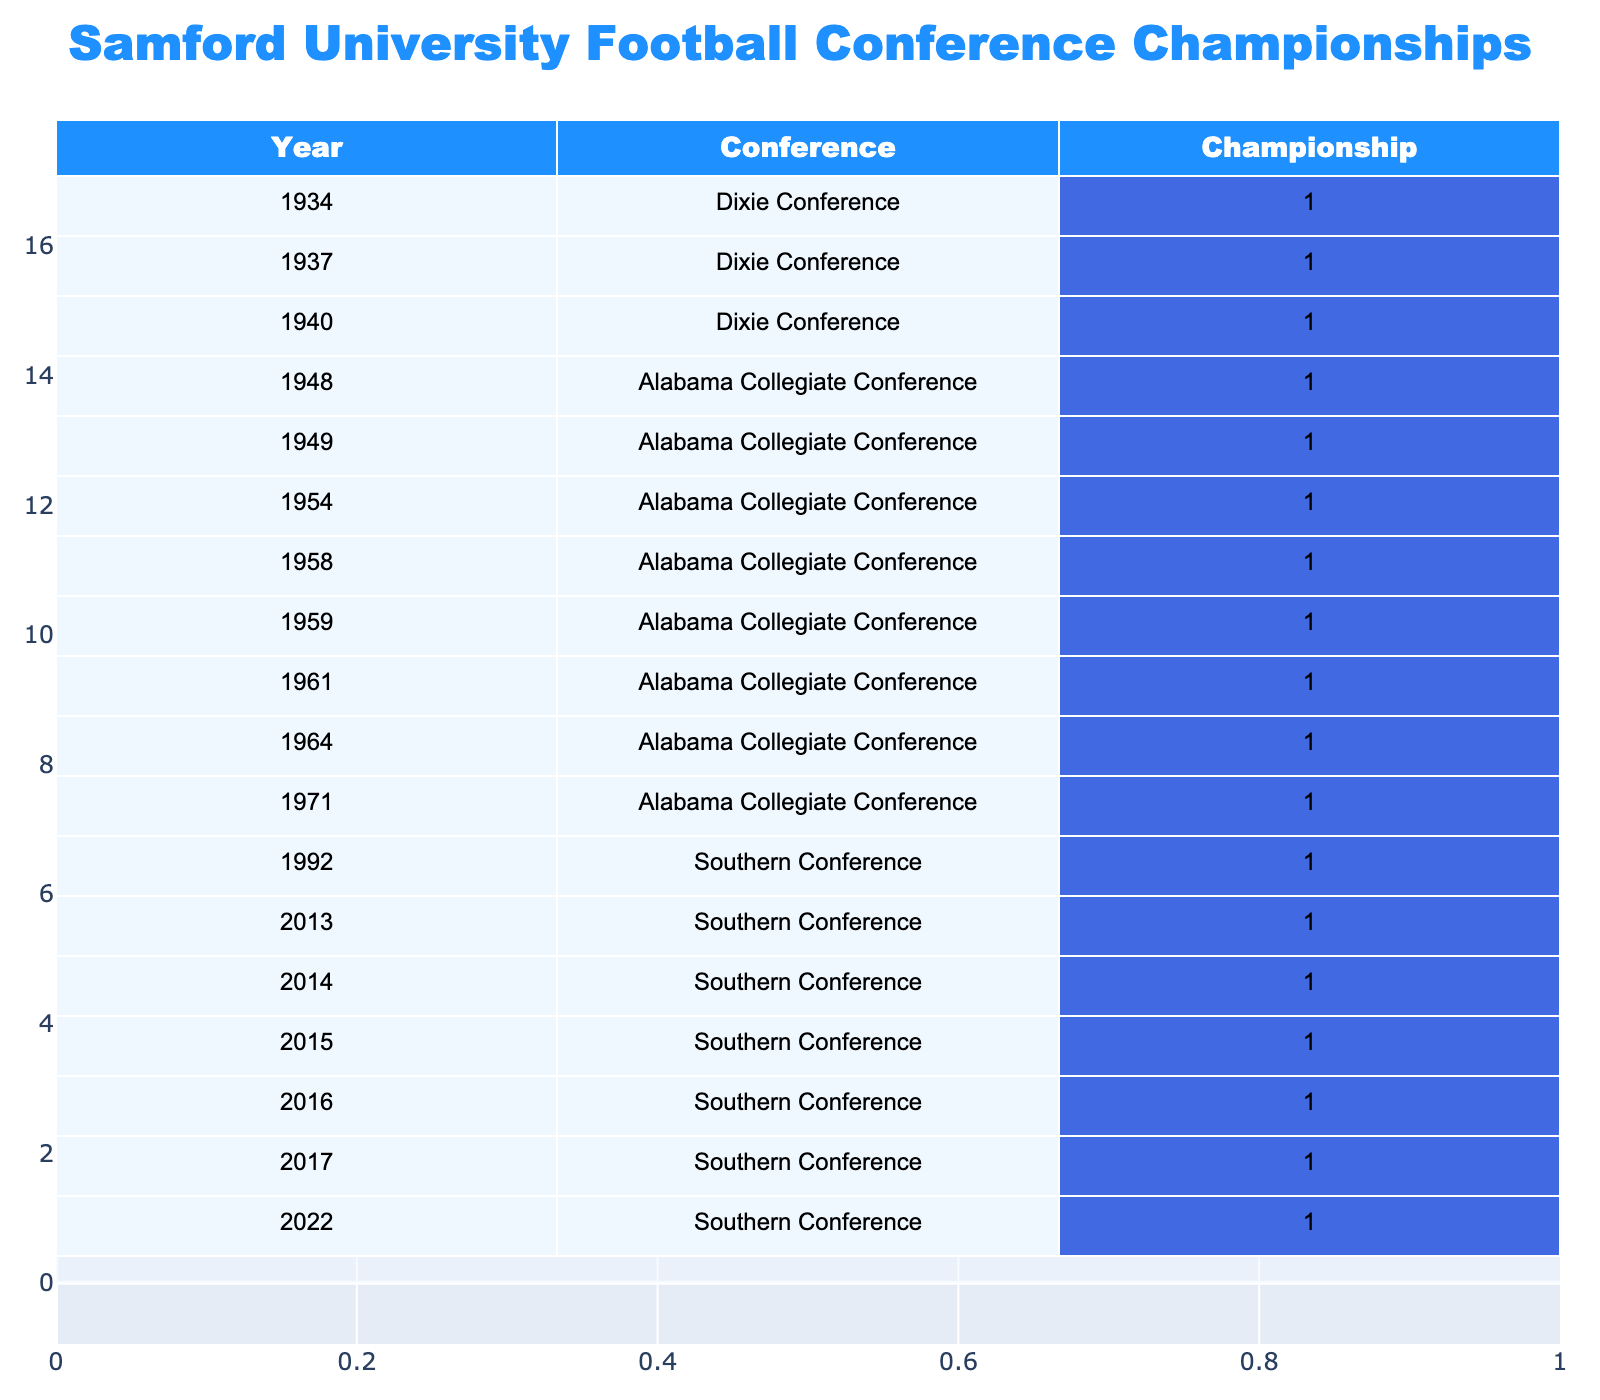What year did Samford University first win a conference championship? The table lists the years Samford won championships starting from 1934, which is the earliest date mentioned.
Answer: 1934 How many total conference championships has Samford University won? By counting all entries in the Championship column, we find that there are 15 championships won across different years, totaling to 15.
Answer: 15 In which conference did Samford University win championships most recently? The most recent year in the table is 2022, and the corresponding conference listed is the Southern Conference, indicating this is the latest conference in which they achieved a championship.
Answer: Southern Conference What is the difference in years between Samford University's first and last conference championship win? The first championship win is in 1934 and the most recent is in 2022. The difference in years is calculated as 2022 - 1934 = 88 years.
Answer: 88 years Did Samford University ever win a conference championship in the 1960s? There are no entries in the table for the years 1960-1969, indicating that Samford did not win any championships during that decade.
Answer: No What percentage of Samford's championships were won in the Southern Conference? There is a total of 15 championships and 7 of those were won in the Southern Conference. The percentage is calculated as (7/15) * 100 = 46.67%.
Answer: 46.67% In what year did Samford University win its last championship, and how many years after its first championship win did this occur? The last championship year is 2022, while the first is 1934. The difference in years is 2022 - 1934 = 88 years, indicating it took 88 years from the first to the last win.
Answer: 2022, 88 years Which conference had the most number of championships won by Samford University? Counting the number of championships won in each conference, the Alabama Collegiate Conference had 7 championships (1948, 1949, 1954, 1958, 1959, 1961, 1964) which is the highest among all listed conferences.
Answer: Alabama Collegiate Conference How many championships did Samford win in the 2010s decade? In the table, we have 2013, 2014, 2015, 2016, and 2017 listed, amounting to 5 championships won during the 2010s decade.
Answer: 5 Is it true that Samford University has won a championship in every decade from the 1930s to the 2020s? By analyzing the years, we see championships in the 1930s, 1940s, 1950s, 1960s (only once), 1970s, 1990s, 2010s, and 2020s, meaning there is a lack of a championship in the 2000s, making the statement false.
Answer: False 